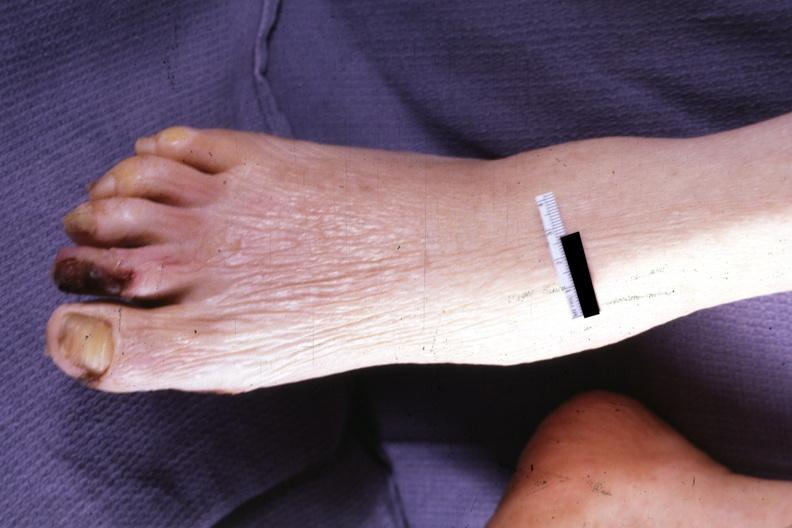what does this image show?
Answer the question using a single word or phrase. Typical small lesion 